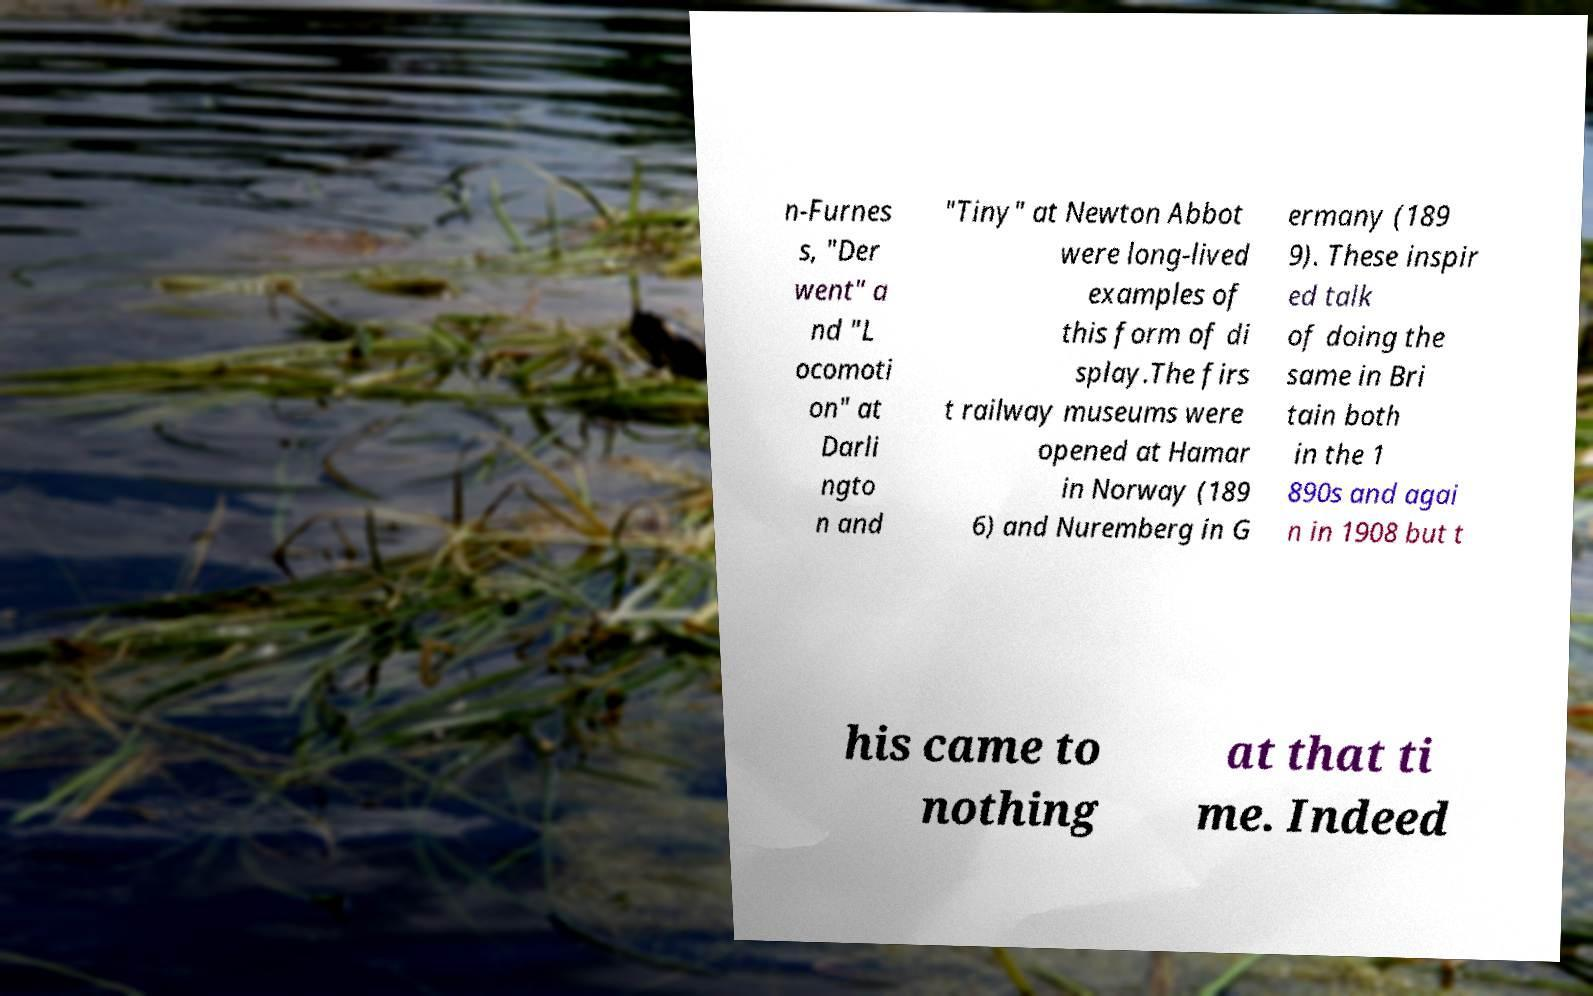For documentation purposes, I need the text within this image transcribed. Could you provide that? n-Furnes s, "Der went" a nd "L ocomoti on" at Darli ngto n and "Tiny" at Newton Abbot were long-lived examples of this form of di splay.The firs t railway museums were opened at Hamar in Norway (189 6) and Nuremberg in G ermany (189 9). These inspir ed talk of doing the same in Bri tain both in the 1 890s and agai n in 1908 but t his came to nothing at that ti me. Indeed 